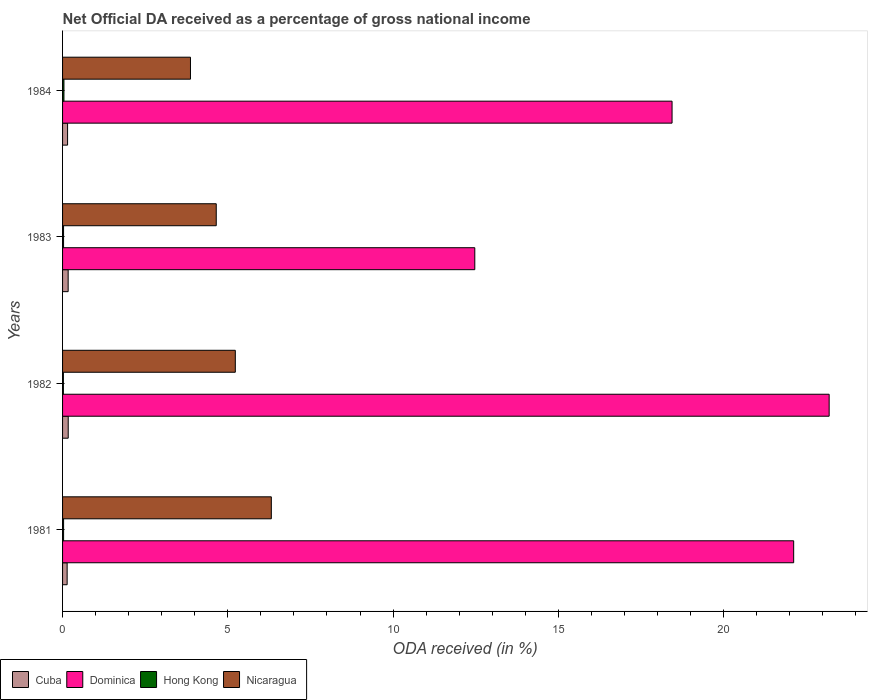How many different coloured bars are there?
Provide a succinct answer. 4. How many bars are there on the 1st tick from the top?
Your response must be concise. 4. How many bars are there on the 4th tick from the bottom?
Ensure brevity in your answer.  4. What is the net official DA received in Cuba in 1983?
Provide a succinct answer. 0.17. Across all years, what is the maximum net official DA received in Cuba?
Make the answer very short. 0.17. Across all years, what is the minimum net official DA received in Cuba?
Your answer should be compact. 0.14. What is the total net official DA received in Hong Kong in the graph?
Provide a short and direct response. 0.13. What is the difference between the net official DA received in Dominica in 1982 and that in 1984?
Offer a terse response. 4.75. What is the difference between the net official DA received in Cuba in 1983 and the net official DA received in Nicaragua in 1982?
Your response must be concise. -5.06. What is the average net official DA received in Nicaragua per year?
Keep it short and to the point. 5.02. In the year 1981, what is the difference between the net official DA received in Dominica and net official DA received in Cuba?
Offer a very short reply. 21.98. In how many years, is the net official DA received in Hong Kong greater than 8 %?
Provide a short and direct response. 0. What is the ratio of the net official DA received in Cuba in 1981 to that in 1982?
Ensure brevity in your answer.  0.81. Is the net official DA received in Nicaragua in 1981 less than that in 1982?
Offer a terse response. No. What is the difference between the highest and the second highest net official DA received in Hong Kong?
Make the answer very short. 0.01. What is the difference between the highest and the lowest net official DA received in Hong Kong?
Your answer should be compact. 0.02. In how many years, is the net official DA received in Dominica greater than the average net official DA received in Dominica taken over all years?
Give a very brief answer. 2. Is it the case that in every year, the sum of the net official DA received in Nicaragua and net official DA received in Cuba is greater than the sum of net official DA received in Dominica and net official DA received in Hong Kong?
Your answer should be very brief. Yes. What does the 1st bar from the top in 1981 represents?
Ensure brevity in your answer.  Nicaragua. What does the 3rd bar from the bottom in 1981 represents?
Your response must be concise. Hong Kong. Is it the case that in every year, the sum of the net official DA received in Hong Kong and net official DA received in Nicaragua is greater than the net official DA received in Dominica?
Your response must be concise. No. How many bars are there?
Give a very brief answer. 16. Are all the bars in the graph horizontal?
Offer a terse response. Yes. How many years are there in the graph?
Keep it short and to the point. 4. Are the values on the major ticks of X-axis written in scientific E-notation?
Ensure brevity in your answer.  No. Where does the legend appear in the graph?
Your response must be concise. Bottom left. How many legend labels are there?
Provide a short and direct response. 4. What is the title of the graph?
Provide a short and direct response. Net Official DA received as a percentage of gross national income. What is the label or title of the X-axis?
Provide a short and direct response. ODA received (in %). What is the ODA received (in %) of Cuba in 1981?
Ensure brevity in your answer.  0.14. What is the ODA received (in %) in Dominica in 1981?
Your response must be concise. 22.12. What is the ODA received (in %) in Hong Kong in 1981?
Ensure brevity in your answer.  0.03. What is the ODA received (in %) in Nicaragua in 1981?
Your answer should be compact. 6.32. What is the ODA received (in %) in Cuba in 1982?
Ensure brevity in your answer.  0.17. What is the ODA received (in %) in Dominica in 1982?
Keep it short and to the point. 23.2. What is the ODA received (in %) in Hong Kong in 1982?
Give a very brief answer. 0.03. What is the ODA received (in %) in Nicaragua in 1982?
Your answer should be very brief. 5.23. What is the ODA received (in %) of Cuba in 1983?
Keep it short and to the point. 0.17. What is the ODA received (in %) in Dominica in 1983?
Offer a terse response. 12.47. What is the ODA received (in %) of Hong Kong in 1983?
Make the answer very short. 0.03. What is the ODA received (in %) in Nicaragua in 1983?
Your response must be concise. 4.65. What is the ODA received (in %) in Cuba in 1984?
Your answer should be compact. 0.15. What is the ODA received (in %) in Dominica in 1984?
Provide a succinct answer. 18.44. What is the ODA received (in %) in Hong Kong in 1984?
Provide a short and direct response. 0.04. What is the ODA received (in %) in Nicaragua in 1984?
Your answer should be very brief. 3.87. Across all years, what is the maximum ODA received (in %) in Cuba?
Your response must be concise. 0.17. Across all years, what is the maximum ODA received (in %) of Dominica?
Ensure brevity in your answer.  23.2. Across all years, what is the maximum ODA received (in %) in Hong Kong?
Ensure brevity in your answer.  0.04. Across all years, what is the maximum ODA received (in %) of Nicaragua?
Your answer should be very brief. 6.32. Across all years, what is the minimum ODA received (in %) in Cuba?
Provide a short and direct response. 0.14. Across all years, what is the minimum ODA received (in %) of Dominica?
Your response must be concise. 12.47. Across all years, what is the minimum ODA received (in %) in Hong Kong?
Provide a short and direct response. 0.03. Across all years, what is the minimum ODA received (in %) of Nicaragua?
Your answer should be very brief. 3.87. What is the total ODA received (in %) in Cuba in the graph?
Give a very brief answer. 0.63. What is the total ODA received (in %) of Dominica in the graph?
Offer a terse response. 76.24. What is the total ODA received (in %) of Hong Kong in the graph?
Keep it short and to the point. 0.13. What is the total ODA received (in %) in Nicaragua in the graph?
Your response must be concise. 20.07. What is the difference between the ODA received (in %) in Cuba in 1981 and that in 1982?
Offer a terse response. -0.03. What is the difference between the ODA received (in %) of Dominica in 1981 and that in 1982?
Your response must be concise. -1.07. What is the difference between the ODA received (in %) of Hong Kong in 1981 and that in 1982?
Provide a short and direct response. 0.01. What is the difference between the ODA received (in %) of Nicaragua in 1981 and that in 1982?
Your response must be concise. 1.09. What is the difference between the ODA received (in %) of Cuba in 1981 and that in 1983?
Keep it short and to the point. -0.03. What is the difference between the ODA received (in %) of Dominica in 1981 and that in 1983?
Your answer should be very brief. 9.65. What is the difference between the ODA received (in %) of Hong Kong in 1981 and that in 1983?
Your answer should be very brief. 0. What is the difference between the ODA received (in %) of Nicaragua in 1981 and that in 1983?
Provide a short and direct response. 1.67. What is the difference between the ODA received (in %) in Cuba in 1981 and that in 1984?
Your answer should be compact. -0.01. What is the difference between the ODA received (in %) of Dominica in 1981 and that in 1984?
Offer a very short reply. 3.68. What is the difference between the ODA received (in %) of Hong Kong in 1981 and that in 1984?
Offer a terse response. -0.01. What is the difference between the ODA received (in %) in Nicaragua in 1981 and that in 1984?
Keep it short and to the point. 2.45. What is the difference between the ODA received (in %) in Cuba in 1982 and that in 1983?
Provide a succinct answer. 0. What is the difference between the ODA received (in %) of Dominica in 1982 and that in 1983?
Offer a terse response. 10.72. What is the difference between the ODA received (in %) in Hong Kong in 1982 and that in 1983?
Give a very brief answer. -0.01. What is the difference between the ODA received (in %) in Nicaragua in 1982 and that in 1983?
Provide a succinct answer. 0.58. What is the difference between the ODA received (in %) in Cuba in 1982 and that in 1984?
Provide a succinct answer. 0.02. What is the difference between the ODA received (in %) in Dominica in 1982 and that in 1984?
Make the answer very short. 4.75. What is the difference between the ODA received (in %) of Hong Kong in 1982 and that in 1984?
Offer a very short reply. -0.02. What is the difference between the ODA received (in %) of Nicaragua in 1982 and that in 1984?
Offer a very short reply. 1.36. What is the difference between the ODA received (in %) of Cuba in 1983 and that in 1984?
Offer a very short reply. 0.02. What is the difference between the ODA received (in %) of Dominica in 1983 and that in 1984?
Ensure brevity in your answer.  -5.97. What is the difference between the ODA received (in %) in Hong Kong in 1983 and that in 1984?
Keep it short and to the point. -0.01. What is the difference between the ODA received (in %) in Nicaragua in 1983 and that in 1984?
Your answer should be compact. 0.78. What is the difference between the ODA received (in %) of Cuba in 1981 and the ODA received (in %) of Dominica in 1982?
Offer a very short reply. -23.06. What is the difference between the ODA received (in %) in Cuba in 1981 and the ODA received (in %) in Hong Kong in 1982?
Keep it short and to the point. 0.11. What is the difference between the ODA received (in %) of Cuba in 1981 and the ODA received (in %) of Nicaragua in 1982?
Ensure brevity in your answer.  -5.09. What is the difference between the ODA received (in %) of Dominica in 1981 and the ODA received (in %) of Hong Kong in 1982?
Offer a terse response. 22.1. What is the difference between the ODA received (in %) in Dominica in 1981 and the ODA received (in %) in Nicaragua in 1982?
Your answer should be very brief. 16.9. What is the difference between the ODA received (in %) in Hong Kong in 1981 and the ODA received (in %) in Nicaragua in 1982?
Provide a succinct answer. -5.2. What is the difference between the ODA received (in %) of Cuba in 1981 and the ODA received (in %) of Dominica in 1983?
Make the answer very short. -12.34. What is the difference between the ODA received (in %) of Cuba in 1981 and the ODA received (in %) of Hong Kong in 1983?
Make the answer very short. 0.11. What is the difference between the ODA received (in %) in Cuba in 1981 and the ODA received (in %) in Nicaragua in 1983?
Offer a terse response. -4.51. What is the difference between the ODA received (in %) in Dominica in 1981 and the ODA received (in %) in Hong Kong in 1983?
Provide a succinct answer. 22.09. What is the difference between the ODA received (in %) in Dominica in 1981 and the ODA received (in %) in Nicaragua in 1983?
Your answer should be very brief. 17.47. What is the difference between the ODA received (in %) in Hong Kong in 1981 and the ODA received (in %) in Nicaragua in 1983?
Make the answer very short. -4.62. What is the difference between the ODA received (in %) of Cuba in 1981 and the ODA received (in %) of Dominica in 1984?
Offer a terse response. -18.3. What is the difference between the ODA received (in %) in Cuba in 1981 and the ODA received (in %) in Hong Kong in 1984?
Make the answer very short. 0.1. What is the difference between the ODA received (in %) of Cuba in 1981 and the ODA received (in %) of Nicaragua in 1984?
Give a very brief answer. -3.73. What is the difference between the ODA received (in %) in Dominica in 1981 and the ODA received (in %) in Hong Kong in 1984?
Your answer should be compact. 22.08. What is the difference between the ODA received (in %) in Dominica in 1981 and the ODA received (in %) in Nicaragua in 1984?
Ensure brevity in your answer.  18.25. What is the difference between the ODA received (in %) in Hong Kong in 1981 and the ODA received (in %) in Nicaragua in 1984?
Ensure brevity in your answer.  -3.84. What is the difference between the ODA received (in %) of Cuba in 1982 and the ODA received (in %) of Dominica in 1983?
Provide a succinct answer. -12.3. What is the difference between the ODA received (in %) in Cuba in 1982 and the ODA received (in %) in Hong Kong in 1983?
Keep it short and to the point. 0.14. What is the difference between the ODA received (in %) in Cuba in 1982 and the ODA received (in %) in Nicaragua in 1983?
Provide a succinct answer. -4.48. What is the difference between the ODA received (in %) of Dominica in 1982 and the ODA received (in %) of Hong Kong in 1983?
Your answer should be compact. 23.17. What is the difference between the ODA received (in %) of Dominica in 1982 and the ODA received (in %) of Nicaragua in 1983?
Your response must be concise. 18.55. What is the difference between the ODA received (in %) of Hong Kong in 1982 and the ODA received (in %) of Nicaragua in 1983?
Make the answer very short. -4.63. What is the difference between the ODA received (in %) of Cuba in 1982 and the ODA received (in %) of Dominica in 1984?
Make the answer very short. -18.27. What is the difference between the ODA received (in %) of Cuba in 1982 and the ODA received (in %) of Hong Kong in 1984?
Your answer should be very brief. 0.13. What is the difference between the ODA received (in %) in Cuba in 1982 and the ODA received (in %) in Nicaragua in 1984?
Your answer should be very brief. -3.7. What is the difference between the ODA received (in %) in Dominica in 1982 and the ODA received (in %) in Hong Kong in 1984?
Give a very brief answer. 23.15. What is the difference between the ODA received (in %) of Dominica in 1982 and the ODA received (in %) of Nicaragua in 1984?
Provide a short and direct response. 19.33. What is the difference between the ODA received (in %) of Hong Kong in 1982 and the ODA received (in %) of Nicaragua in 1984?
Your answer should be very brief. -3.85. What is the difference between the ODA received (in %) of Cuba in 1983 and the ODA received (in %) of Dominica in 1984?
Make the answer very short. -18.27. What is the difference between the ODA received (in %) in Cuba in 1983 and the ODA received (in %) in Hong Kong in 1984?
Give a very brief answer. 0.13. What is the difference between the ODA received (in %) in Cuba in 1983 and the ODA received (in %) in Nicaragua in 1984?
Keep it short and to the point. -3.7. What is the difference between the ODA received (in %) in Dominica in 1983 and the ODA received (in %) in Hong Kong in 1984?
Give a very brief answer. 12.43. What is the difference between the ODA received (in %) in Dominica in 1983 and the ODA received (in %) in Nicaragua in 1984?
Keep it short and to the point. 8.6. What is the difference between the ODA received (in %) in Hong Kong in 1983 and the ODA received (in %) in Nicaragua in 1984?
Ensure brevity in your answer.  -3.84. What is the average ODA received (in %) of Cuba per year?
Give a very brief answer. 0.16. What is the average ODA received (in %) of Dominica per year?
Make the answer very short. 19.06. What is the average ODA received (in %) in Hong Kong per year?
Offer a terse response. 0.03. What is the average ODA received (in %) of Nicaragua per year?
Your answer should be compact. 5.02. In the year 1981, what is the difference between the ODA received (in %) in Cuba and ODA received (in %) in Dominica?
Offer a terse response. -21.98. In the year 1981, what is the difference between the ODA received (in %) of Cuba and ODA received (in %) of Hong Kong?
Provide a short and direct response. 0.11. In the year 1981, what is the difference between the ODA received (in %) of Cuba and ODA received (in %) of Nicaragua?
Give a very brief answer. -6.18. In the year 1981, what is the difference between the ODA received (in %) of Dominica and ODA received (in %) of Hong Kong?
Provide a short and direct response. 22.09. In the year 1981, what is the difference between the ODA received (in %) in Dominica and ODA received (in %) in Nicaragua?
Make the answer very short. 15.81. In the year 1981, what is the difference between the ODA received (in %) of Hong Kong and ODA received (in %) of Nicaragua?
Ensure brevity in your answer.  -6.29. In the year 1982, what is the difference between the ODA received (in %) of Cuba and ODA received (in %) of Dominica?
Give a very brief answer. -23.03. In the year 1982, what is the difference between the ODA received (in %) of Cuba and ODA received (in %) of Hong Kong?
Provide a short and direct response. 0.15. In the year 1982, what is the difference between the ODA received (in %) of Cuba and ODA received (in %) of Nicaragua?
Offer a terse response. -5.06. In the year 1982, what is the difference between the ODA received (in %) in Dominica and ODA received (in %) in Hong Kong?
Provide a short and direct response. 23.17. In the year 1982, what is the difference between the ODA received (in %) of Dominica and ODA received (in %) of Nicaragua?
Make the answer very short. 17.97. In the year 1982, what is the difference between the ODA received (in %) of Hong Kong and ODA received (in %) of Nicaragua?
Keep it short and to the point. -5.2. In the year 1983, what is the difference between the ODA received (in %) of Cuba and ODA received (in %) of Dominica?
Make the answer very short. -12.3. In the year 1983, what is the difference between the ODA received (in %) of Cuba and ODA received (in %) of Hong Kong?
Make the answer very short. 0.14. In the year 1983, what is the difference between the ODA received (in %) of Cuba and ODA received (in %) of Nicaragua?
Your answer should be very brief. -4.48. In the year 1983, what is the difference between the ODA received (in %) of Dominica and ODA received (in %) of Hong Kong?
Your response must be concise. 12.44. In the year 1983, what is the difference between the ODA received (in %) in Dominica and ODA received (in %) in Nicaragua?
Keep it short and to the point. 7.82. In the year 1983, what is the difference between the ODA received (in %) of Hong Kong and ODA received (in %) of Nicaragua?
Make the answer very short. -4.62. In the year 1984, what is the difference between the ODA received (in %) in Cuba and ODA received (in %) in Dominica?
Make the answer very short. -18.29. In the year 1984, what is the difference between the ODA received (in %) of Cuba and ODA received (in %) of Hong Kong?
Your answer should be compact. 0.11. In the year 1984, what is the difference between the ODA received (in %) of Cuba and ODA received (in %) of Nicaragua?
Offer a very short reply. -3.72. In the year 1984, what is the difference between the ODA received (in %) in Dominica and ODA received (in %) in Hong Kong?
Your answer should be compact. 18.4. In the year 1984, what is the difference between the ODA received (in %) of Dominica and ODA received (in %) of Nicaragua?
Ensure brevity in your answer.  14.57. In the year 1984, what is the difference between the ODA received (in %) of Hong Kong and ODA received (in %) of Nicaragua?
Keep it short and to the point. -3.83. What is the ratio of the ODA received (in %) in Cuba in 1981 to that in 1982?
Offer a terse response. 0.81. What is the ratio of the ODA received (in %) of Dominica in 1981 to that in 1982?
Give a very brief answer. 0.95. What is the ratio of the ODA received (in %) in Hong Kong in 1981 to that in 1982?
Your answer should be compact. 1.25. What is the ratio of the ODA received (in %) in Nicaragua in 1981 to that in 1982?
Your answer should be compact. 1.21. What is the ratio of the ODA received (in %) of Cuba in 1981 to that in 1983?
Your answer should be compact. 0.82. What is the ratio of the ODA received (in %) in Dominica in 1981 to that in 1983?
Your answer should be compact. 1.77. What is the ratio of the ODA received (in %) of Hong Kong in 1981 to that in 1983?
Your answer should be very brief. 1.04. What is the ratio of the ODA received (in %) in Nicaragua in 1981 to that in 1983?
Give a very brief answer. 1.36. What is the ratio of the ODA received (in %) in Cuba in 1981 to that in 1984?
Provide a succinct answer. 0.91. What is the ratio of the ODA received (in %) of Dominica in 1981 to that in 1984?
Give a very brief answer. 1.2. What is the ratio of the ODA received (in %) in Hong Kong in 1981 to that in 1984?
Your answer should be very brief. 0.74. What is the ratio of the ODA received (in %) of Nicaragua in 1981 to that in 1984?
Your answer should be compact. 1.63. What is the ratio of the ODA received (in %) of Dominica in 1982 to that in 1983?
Keep it short and to the point. 1.86. What is the ratio of the ODA received (in %) of Hong Kong in 1982 to that in 1983?
Your answer should be very brief. 0.83. What is the ratio of the ODA received (in %) of Nicaragua in 1982 to that in 1983?
Offer a very short reply. 1.12. What is the ratio of the ODA received (in %) in Cuba in 1982 to that in 1984?
Make the answer very short. 1.13. What is the ratio of the ODA received (in %) of Dominica in 1982 to that in 1984?
Your answer should be compact. 1.26. What is the ratio of the ODA received (in %) of Hong Kong in 1982 to that in 1984?
Make the answer very short. 0.6. What is the ratio of the ODA received (in %) in Nicaragua in 1982 to that in 1984?
Your answer should be very brief. 1.35. What is the ratio of the ODA received (in %) of Cuba in 1983 to that in 1984?
Ensure brevity in your answer.  1.12. What is the ratio of the ODA received (in %) of Dominica in 1983 to that in 1984?
Provide a succinct answer. 0.68. What is the ratio of the ODA received (in %) of Hong Kong in 1983 to that in 1984?
Keep it short and to the point. 0.72. What is the ratio of the ODA received (in %) in Nicaragua in 1983 to that in 1984?
Your answer should be very brief. 1.2. What is the difference between the highest and the second highest ODA received (in %) of Cuba?
Offer a terse response. 0. What is the difference between the highest and the second highest ODA received (in %) in Dominica?
Your answer should be very brief. 1.07. What is the difference between the highest and the second highest ODA received (in %) in Hong Kong?
Offer a very short reply. 0.01. What is the difference between the highest and the second highest ODA received (in %) of Nicaragua?
Offer a terse response. 1.09. What is the difference between the highest and the lowest ODA received (in %) of Cuba?
Give a very brief answer. 0.03. What is the difference between the highest and the lowest ODA received (in %) of Dominica?
Offer a terse response. 10.72. What is the difference between the highest and the lowest ODA received (in %) of Hong Kong?
Your response must be concise. 0.02. What is the difference between the highest and the lowest ODA received (in %) of Nicaragua?
Provide a succinct answer. 2.45. 